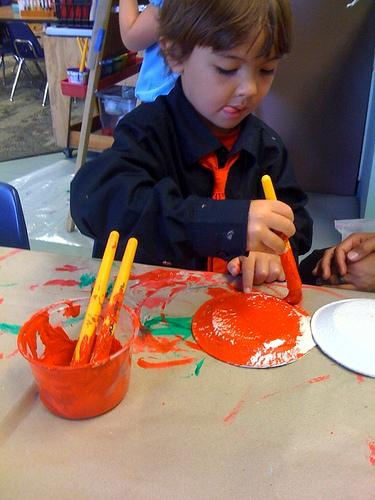Which one of the paint is safe for children art work? Please explain your reasoning. acrylic paint. There is certain kind of paint that is easy to wash out. it contains water which will help with cleanup. 